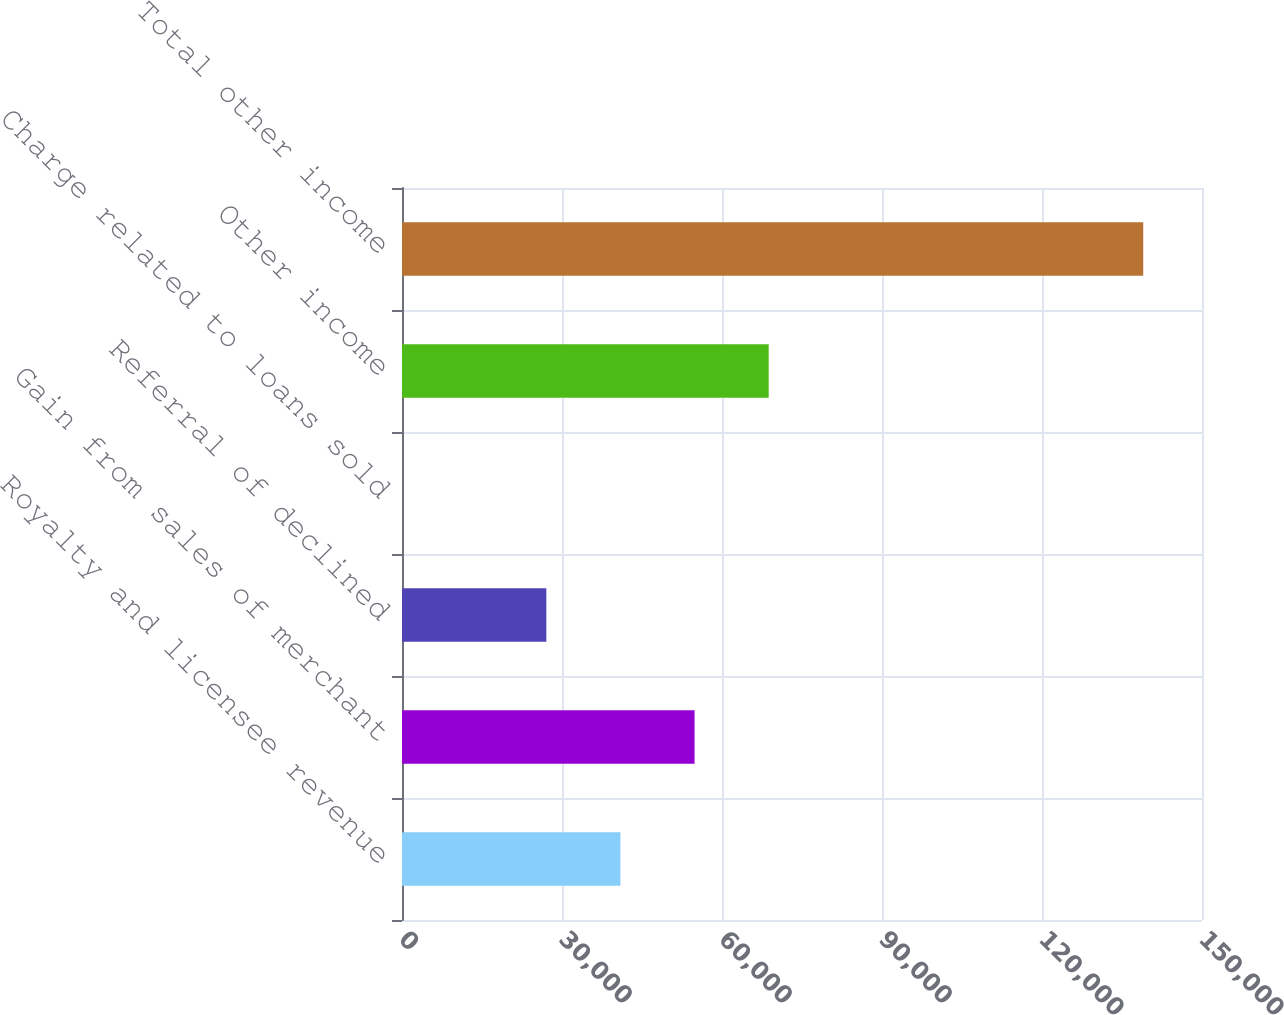Convert chart to OTSL. <chart><loc_0><loc_0><loc_500><loc_500><bar_chart><fcel>Royalty and licensee revenue<fcel>Gain from sales of merchant<fcel>Referral of declined<fcel>Charge related to loans sold<fcel>Other income<fcel>Total other income<nl><fcel>40958.8<fcel>54856.7<fcel>27061<fcel>2.52<fcel>68754.6<fcel>138981<nl></chart> 